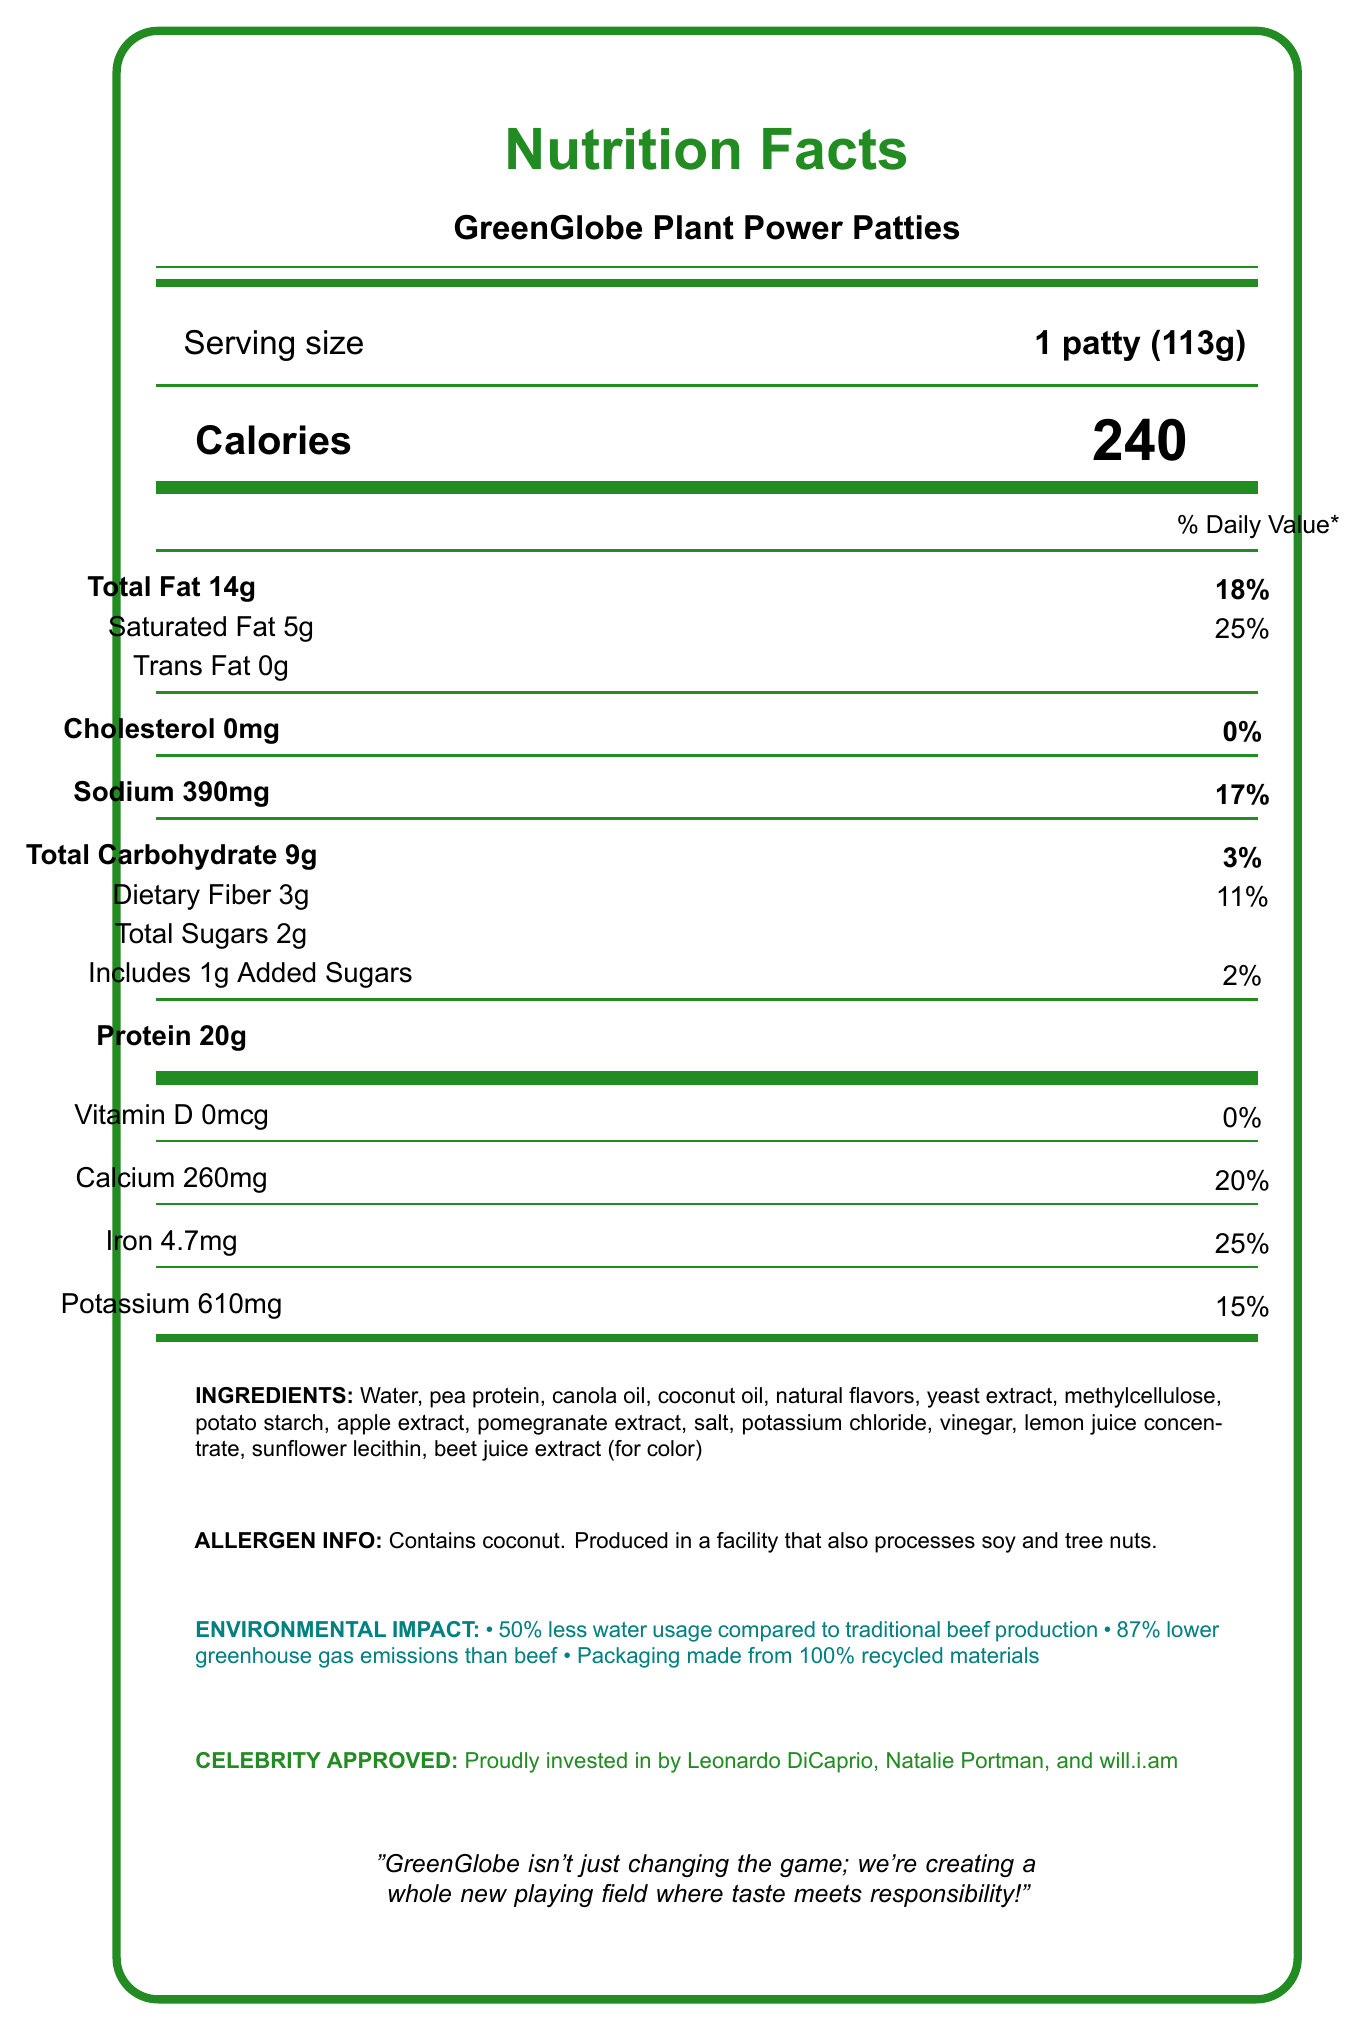what is the serving size for GreenGlobe Plant Power Patties? The document states the serving size as "1 patty (113g)" next to the "Serving size" label.
Answer: 1 patty (113g) how many calories are in one serving? The document lists "Calories" as 240, located in the section beneath the serving size.
Answer: 240 how much total fat is in one patty? "Total Fat" is shown as 14g with an 18% Daily Value on the document.
Answer: 14g how many grams of protein does one patty contain? The protein content is listed as 20g under the "Protein" section of the document.
Answer: 20g how much iron is in one patty? The document specifies "Iron" content as 4.7mg with a Daily Value of 25%.
Answer: 4.7mg which of the following is a listed environmental benefit of GreenGlobe Plant Power Patties? A. 10% less water usage B. 50% less water usage C. 70% less greenhouse gas emissions The document mentions "50% less water usage compared to traditional beef production" as an environmental benefit.
Answer: B who are some of the celebrity investors in GreenGlobe Plant Power Patties? A. Brad Pitt, Emma Watson, Jamie Foxx B. Leonardo DiCaprio, Natalie Portman, will.i.am C. Ryan Reynolds, Kristen Bell, Snoop Dogg The document highlights that Leonardo DiCaprio, Natalie Portman, and will.i.am are investors.
Answer: B do these patties contain any cholesterol? The document lists "Cholesterol 0mg" next to the "Cholesterol" label, with a 0% Daily Value.
Answer: No summarize the main idea of the document. The document provides a detailed nutrition label, emphasizes environmental benefits like reduced water usage and greenhouse gas emissions, and mentions investment from celebrities such as Leonardo DiCaprio, Natalie Portman, and will.i.am. It also includes ingredient and allergen information.
Answer: GreenGlobe Plant Power Patties are plant-based meat alternatives offering high-protein, lower environmental impact, and have celebrity endorsements. how much of the daily value of calcium does one patty provide? The document lists "Calcium 260mg" with a 20% Daily Value under the "Calcium" section.
Answer: 20% can the document tell us the retail price of the GreenGlobe Plant Power Patties? The document focuses on nutritional facts, environmental claims, and celebrity investments but does not provide any pricing details.
Answer: Not enough information 